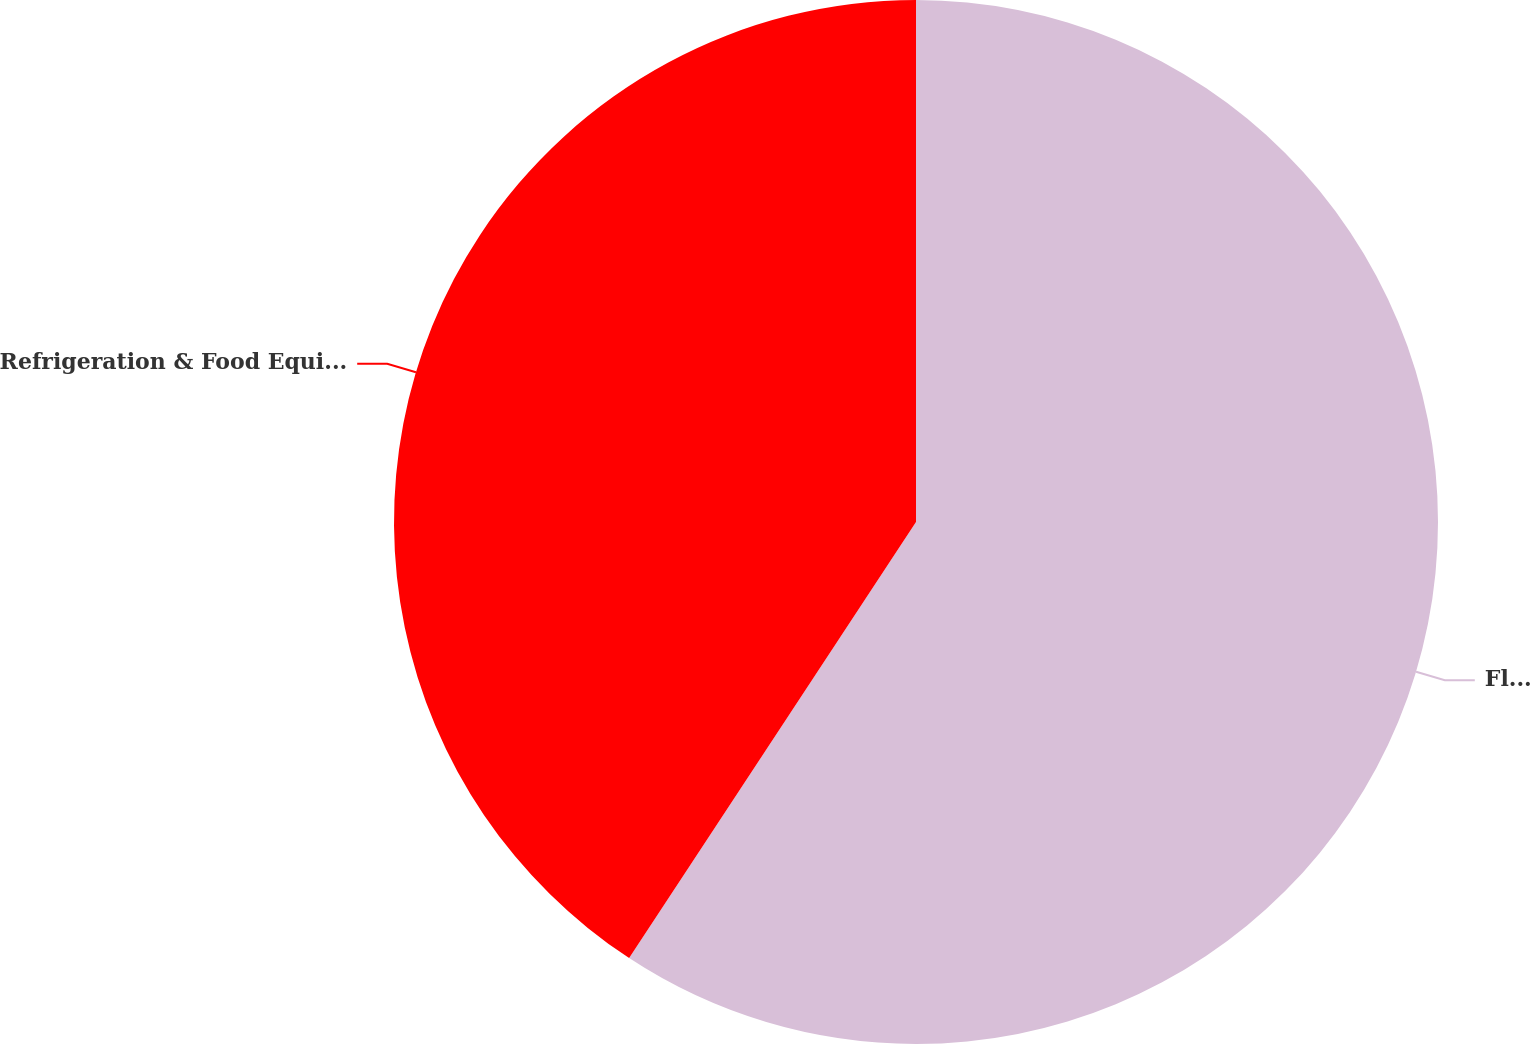Convert chart to OTSL. <chart><loc_0><loc_0><loc_500><loc_500><pie_chart><fcel>Fluids<fcel>Refrigeration & Food Equipment<nl><fcel>59.26%<fcel>40.74%<nl></chart> 